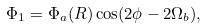<formula> <loc_0><loc_0><loc_500><loc_500>\Phi _ { 1 } = \Phi _ { a } ( R ) \cos ( 2 \phi - 2 \Omega _ { b } ) ,</formula> 